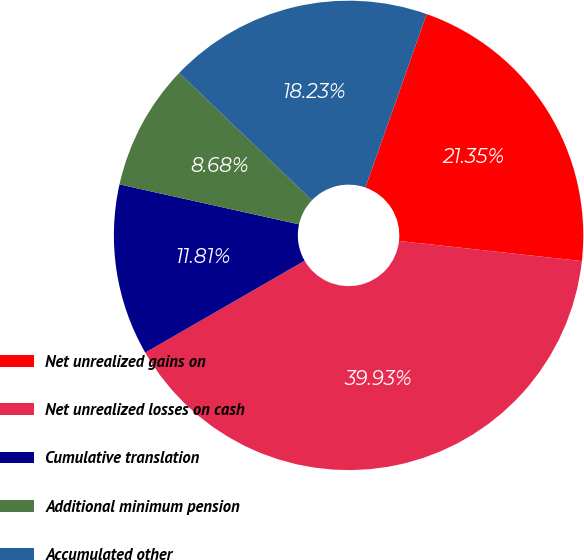Convert chart. <chart><loc_0><loc_0><loc_500><loc_500><pie_chart><fcel>Net unrealized gains on<fcel>Net unrealized losses on cash<fcel>Cumulative translation<fcel>Additional minimum pension<fcel>Accumulated other<nl><fcel>21.35%<fcel>39.93%<fcel>11.81%<fcel>8.68%<fcel>18.23%<nl></chart> 